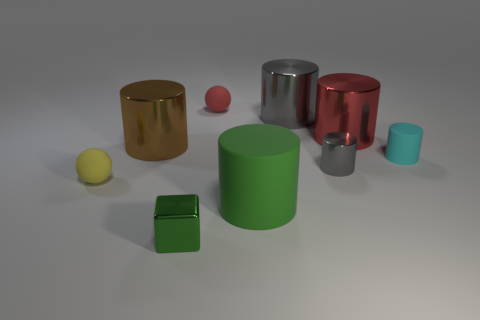Subtract all brown cylinders. How many cylinders are left? 5 Subtract all green cylinders. How many cylinders are left? 5 Subtract all yellow cylinders. Subtract all red spheres. How many cylinders are left? 6 Add 1 tiny cubes. How many objects exist? 10 Subtract all balls. How many objects are left? 7 Add 3 small brown cylinders. How many small brown cylinders exist? 3 Subtract 0 brown balls. How many objects are left? 9 Subtract all green metallic cylinders. Subtract all big brown metal things. How many objects are left? 8 Add 1 small green cubes. How many small green cubes are left? 2 